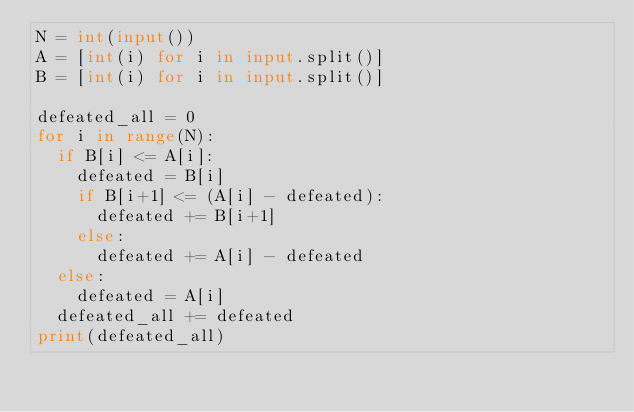<code> <loc_0><loc_0><loc_500><loc_500><_Python_>N = int(input())
A = [int(i) for i in input.split()]
B = [int(i) for i in input.split()]
 
defeated_all = 0
for i in range(N):
  if B[i] <= A[i]:
    defeated = B[i]
    if B[i+1] <= (A[i] - defeated):
      defeated += B[i+1]
    else:
      defeated += A[i] - defeated
  else:
    defeated = A[i]
  defeated_all += defeated
print(defeated_all)</code> 